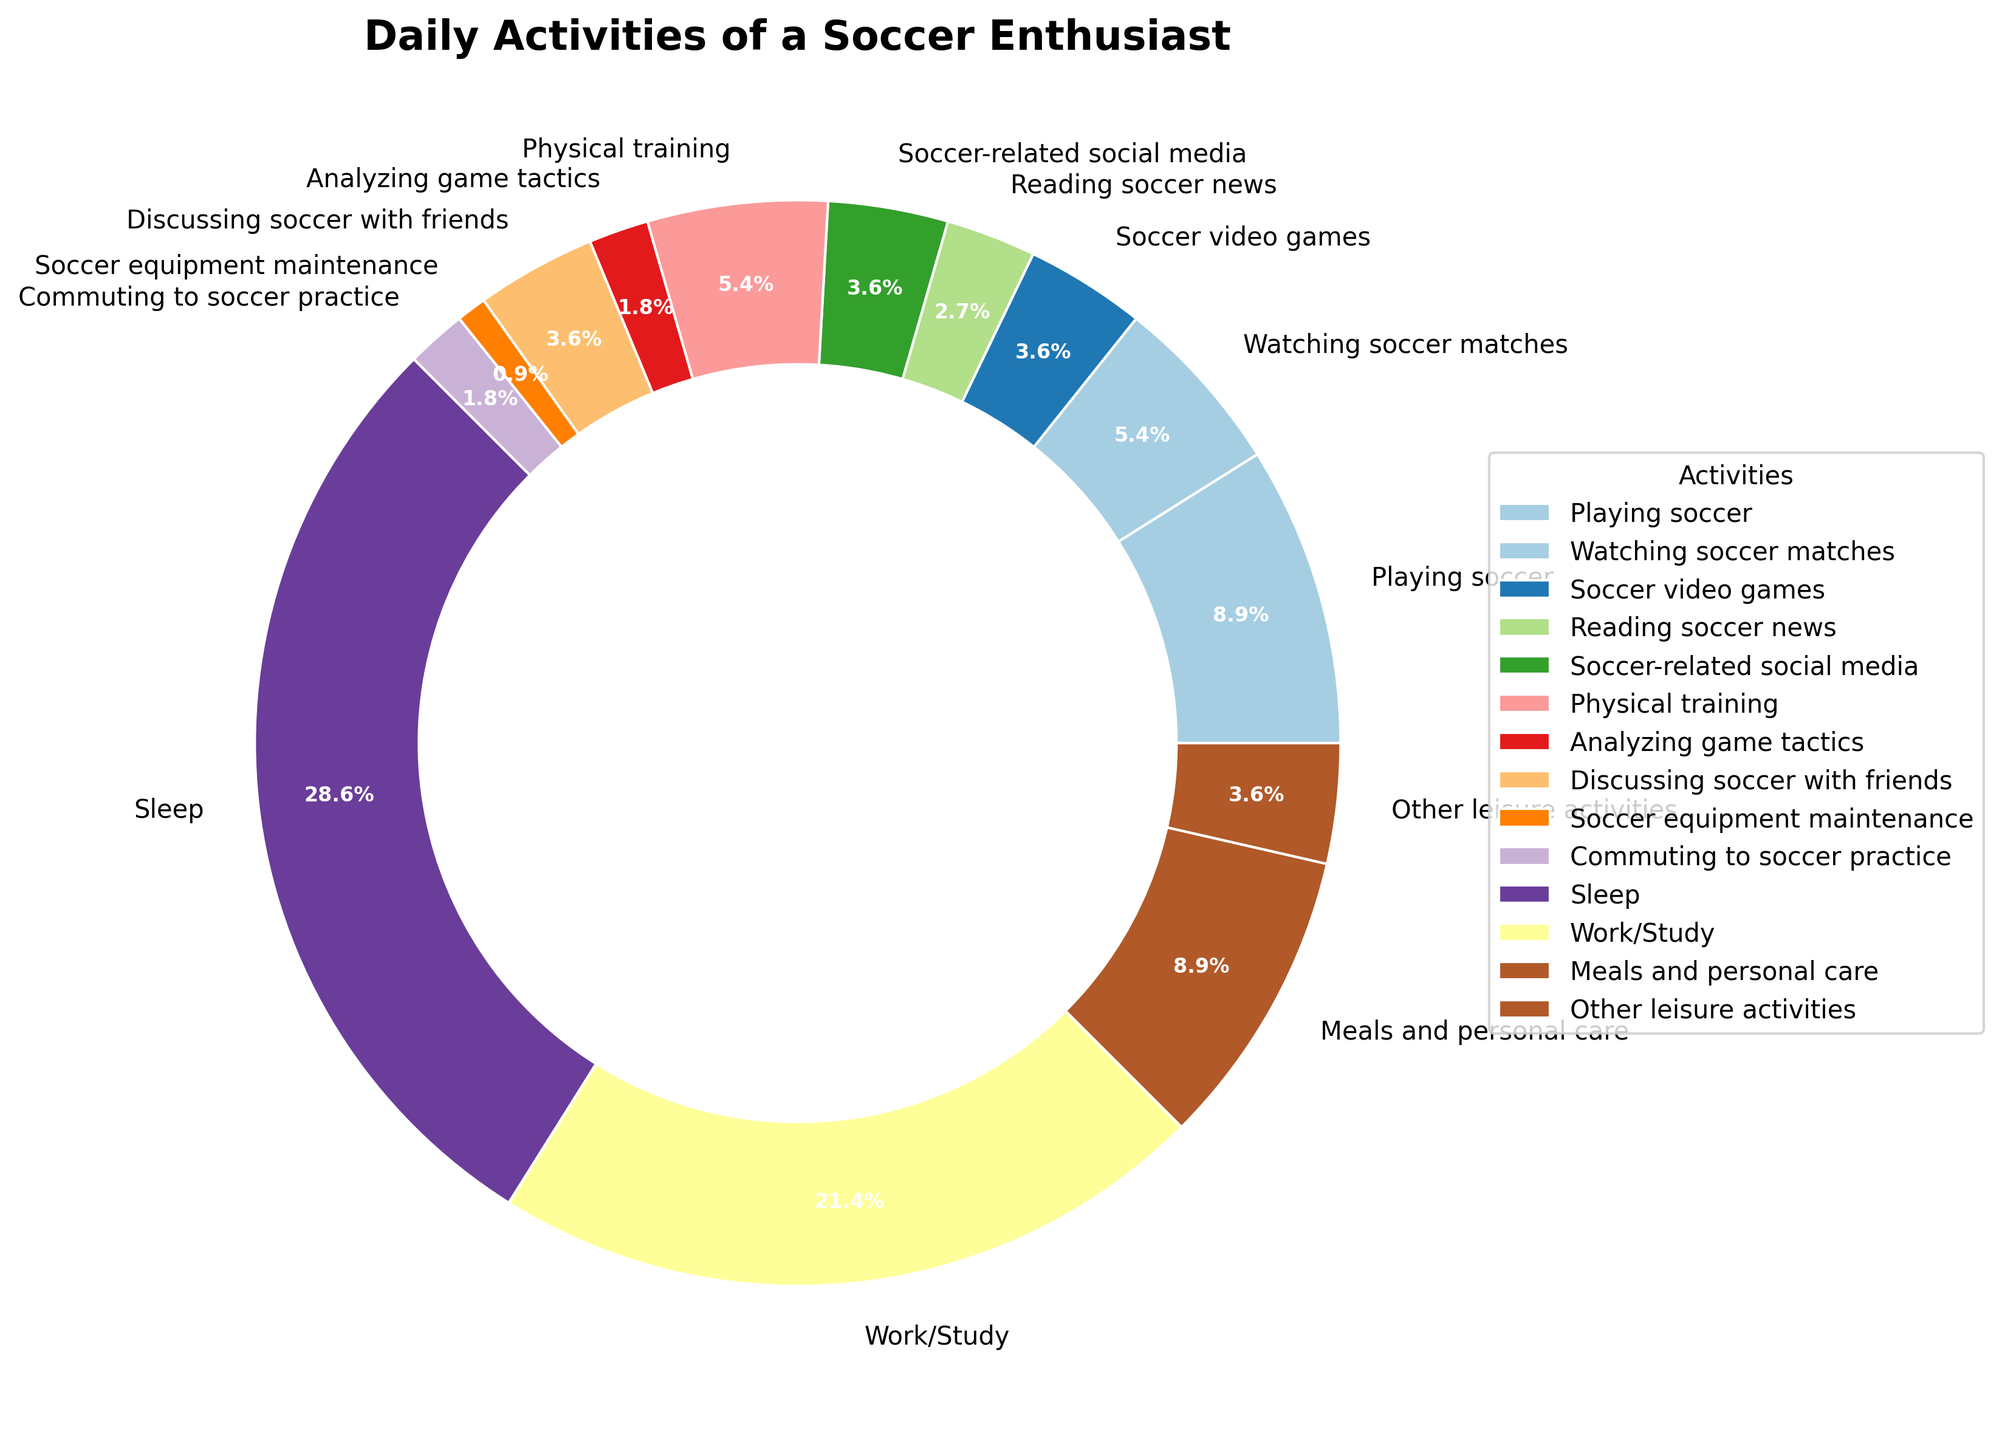Which activity takes up the most time in a day? By quickly scanning the slices, we can see that "Sleep" has the largest slice among all the activities in the pie chart.
Answer: Sleep What percentage of the day is spent on soccer-related activities? Adding the hours of soccer-related activities (Playing soccer, Watching soccer matches, Soccer video games, Reading soccer news, Soccer-related social media, Physical training, Analyzing game tactics, Discussing soccer with friends, Soccer equipment maintenance, Commuting to soccer practice) gives us a total of 9.5 hours. There are 24 hours in a day, so the percentage is (9.5/24) * 100.
Answer: 39.6% How does the time spent on meals and personal care compare to playing soccer? The pie chart shows that "Meals and personal care" is 2.5 hours, and "Playing soccer" is also 2.5 hours. Thus, the time spent on both activities is equal.
Answer: Equal Which activity occupies the least amount of time? "Soccer equipment maintenance" has the smallest slice, corresponding to 0.25 hours.
Answer: Soccer equipment maintenance What is the combined percentage of time spent on watching soccer matches, soccer video games, and discussing soccer with friends? Adding the hours for these activities gives us (1.5 + 1 + 1) = 3.5 hours. The percentage is (3.5/24) * 100.
Answer: 14.6% Which has a larger share: physical training or watching soccer matches? The chart shows that physical training (1.5 hours) has a larger slice than watching soccer matches (1.5 hours), indicating they occupy the same amount of time.
Answer: Equal What is the total amount of time spent on non-soccer-related leisure activities? "Other leisure activities" is depicted as 1 hour in the pie chart.
Answer: 1 hour What's the difference in time between work/study and sleeping? The pie chart indicates that sleep is 8 hours, and work/study is 6 hours. The difference is (8 - 6).
Answer: 2 hours Which activity is closest in duration to the time spent commuting to soccer practice? "Analyzing game tactics" has a duration of 0.5 hours, which is the same as "Commuting to soccer practice."
Answer: Analyzing game tactics 